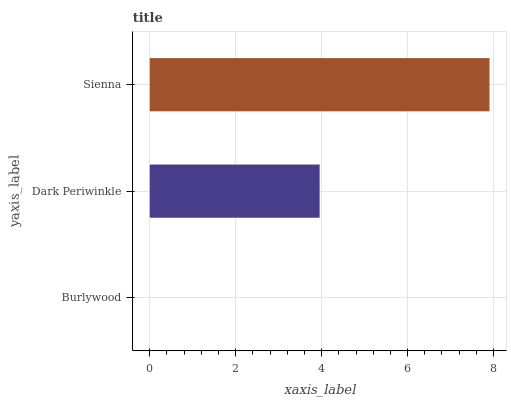Is Burlywood the minimum?
Answer yes or no. Yes. Is Sienna the maximum?
Answer yes or no. Yes. Is Dark Periwinkle the minimum?
Answer yes or no. No. Is Dark Periwinkle the maximum?
Answer yes or no. No. Is Dark Periwinkle greater than Burlywood?
Answer yes or no. Yes. Is Burlywood less than Dark Periwinkle?
Answer yes or no. Yes. Is Burlywood greater than Dark Periwinkle?
Answer yes or no. No. Is Dark Periwinkle less than Burlywood?
Answer yes or no. No. Is Dark Periwinkle the high median?
Answer yes or no. Yes. Is Dark Periwinkle the low median?
Answer yes or no. Yes. Is Sienna the high median?
Answer yes or no. No. Is Sienna the low median?
Answer yes or no. No. 